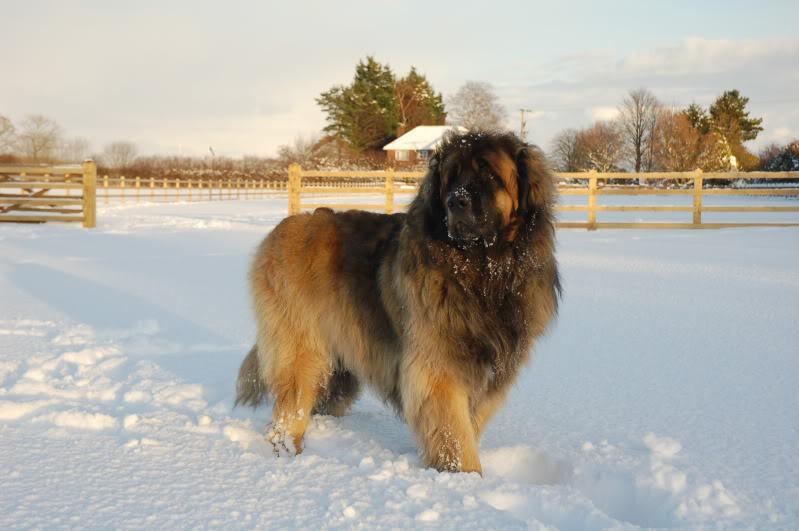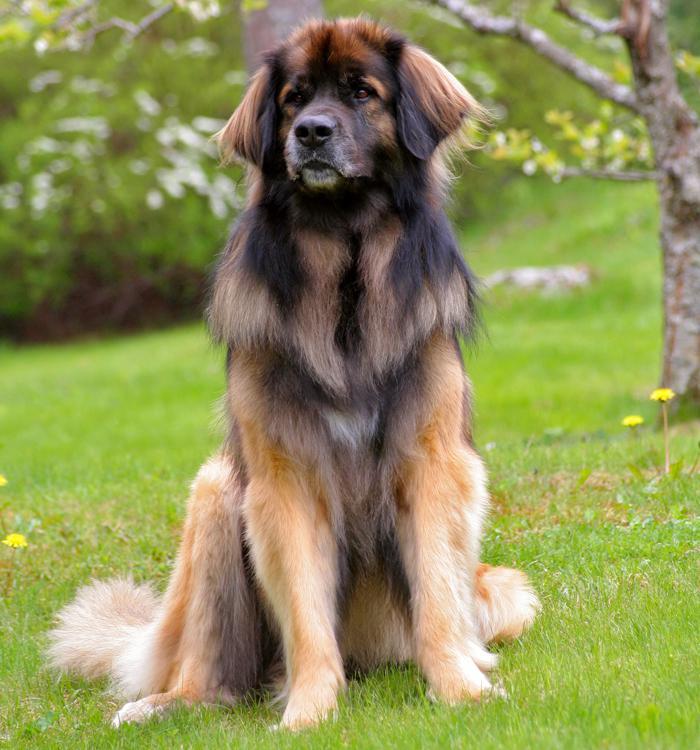The first image is the image on the left, the second image is the image on the right. Evaluate the accuracy of this statement regarding the images: "Both images show a single adult dog looking left.". Is it true? Answer yes or no. Yes. The first image is the image on the left, the second image is the image on the right. Given the left and right images, does the statement "At least one image in the pair shows at least two mammals." hold true? Answer yes or no. No. 